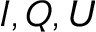Convert formula to latex. <formula><loc_0><loc_0><loc_500><loc_500>I , Q , U</formula> 